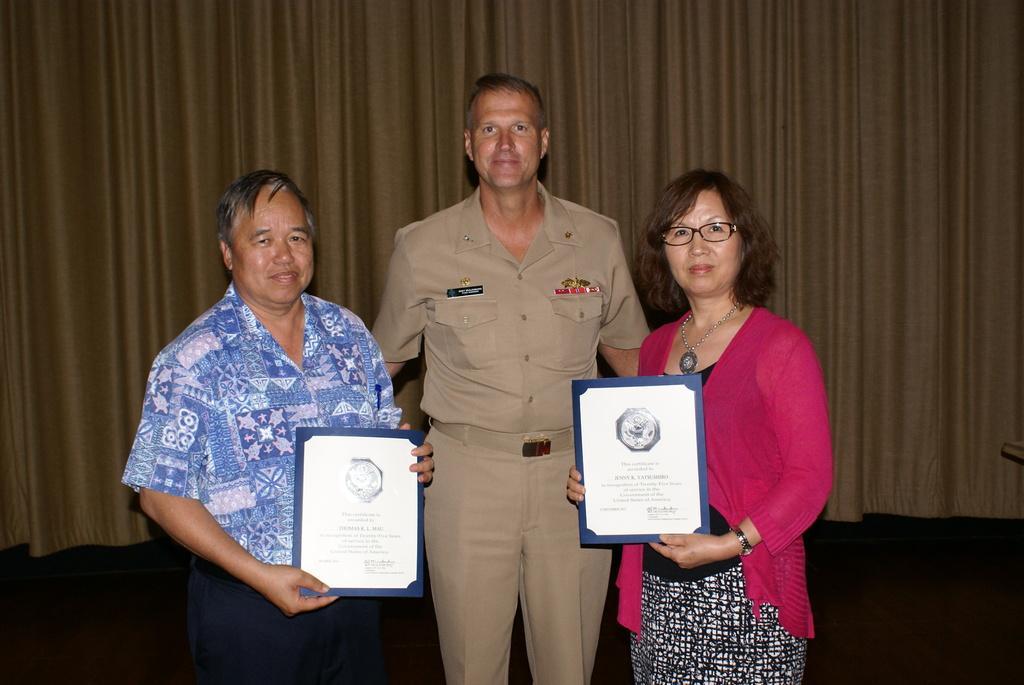Could you give a brief overview of what you see in this image? In this picture I can see three persons standing, in which two persons are holding certificates, and in the background there is a curtain. 